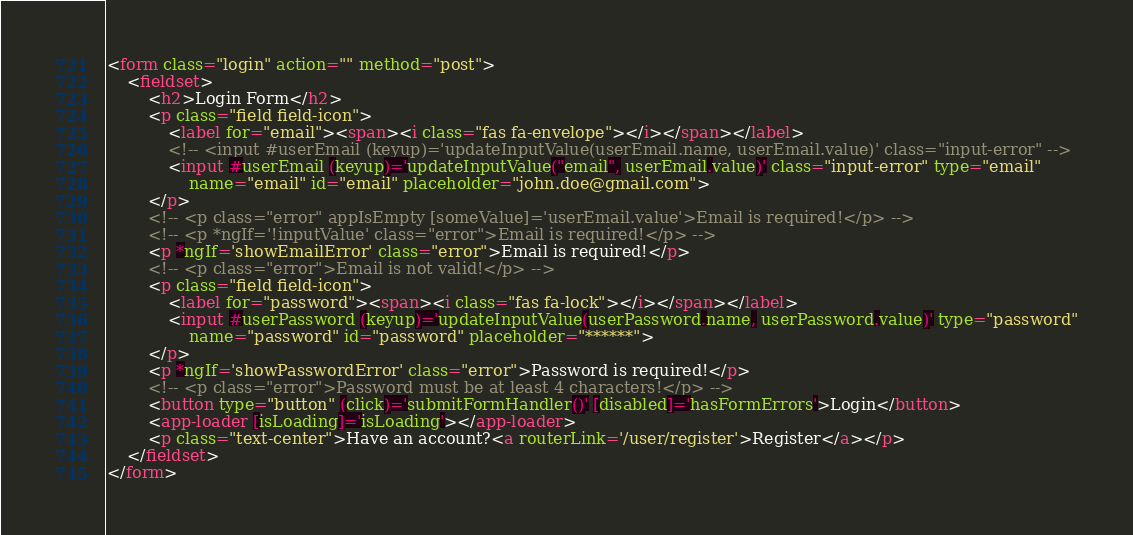Convert code to text. <code><loc_0><loc_0><loc_500><loc_500><_HTML_><form class="login" action="" method="post">
    <fieldset>
        <h2>Login Form</h2>
        <p class="field field-icon">
            <label for="email"><span><i class="fas fa-envelope"></i></span></label>
            <!-- <input #userEmail (keyup)='updateInputValue(userEmail.name, userEmail.value)' class="input-error" -->
            <input #userEmail (keyup)='updateInputValue("email", userEmail.value)' class="input-error" type="email"
                name="email" id="email" placeholder="john.doe@gmail.com">
        </p>
        <!-- <p class="error" appIsEmpty [someValue]='userEmail.value'>Email is required!</p> -->
        <!-- <p *ngIf='!inputValue' class="error">Email is required!</p> -->
        <p *ngIf='showEmailError' class="error">Email is required!</p>
        <!-- <p class="error">Email is not valid!</p> -->
        <p class="field field-icon">
            <label for="password"><span><i class="fas fa-lock"></i></span></label>
            <input #userPassword (keyup)='updateInputValue(userPassword.name, userPassword.value)' type="password"
                name="password" id="password" placeholder="******">
        </p>
        <p *ngIf='showPasswordError' class="error">Password is required!</p>
        <!-- <p class="error">Password must be at least 4 characters!</p> -->
        <button type="button" (click)='submitFormHandler()' [disabled]='hasFormErrors'>Login</button>
        <app-loader [isLoading]='isLoading'></app-loader>
        <p class="text-center">Have an account?<a routerLink='/user/register'>Register</a></p>
    </fieldset>
</form></code> 